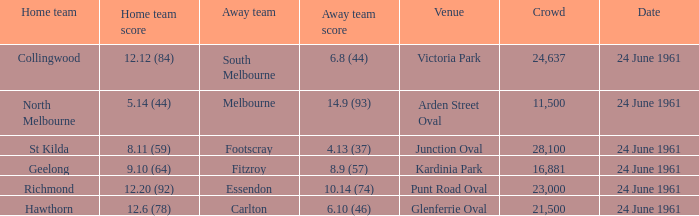What was the mean audience size at games conducted at glenferrie oval? 21500.0. Can you give me this table as a dict? {'header': ['Home team', 'Home team score', 'Away team', 'Away team score', 'Venue', 'Crowd', 'Date'], 'rows': [['Collingwood', '12.12 (84)', 'South Melbourne', '6.8 (44)', 'Victoria Park', '24,637', '24 June 1961'], ['North Melbourne', '5.14 (44)', 'Melbourne', '14.9 (93)', 'Arden Street Oval', '11,500', '24 June 1961'], ['St Kilda', '8.11 (59)', 'Footscray', '4.13 (37)', 'Junction Oval', '28,100', '24 June 1961'], ['Geelong', '9.10 (64)', 'Fitzroy', '8.9 (57)', 'Kardinia Park', '16,881', '24 June 1961'], ['Richmond', '12.20 (92)', 'Essendon', '10.14 (74)', 'Punt Road Oval', '23,000', '24 June 1961'], ['Hawthorn', '12.6 (78)', 'Carlton', '6.10 (46)', 'Glenferrie Oval', '21,500', '24 June 1961']]} 